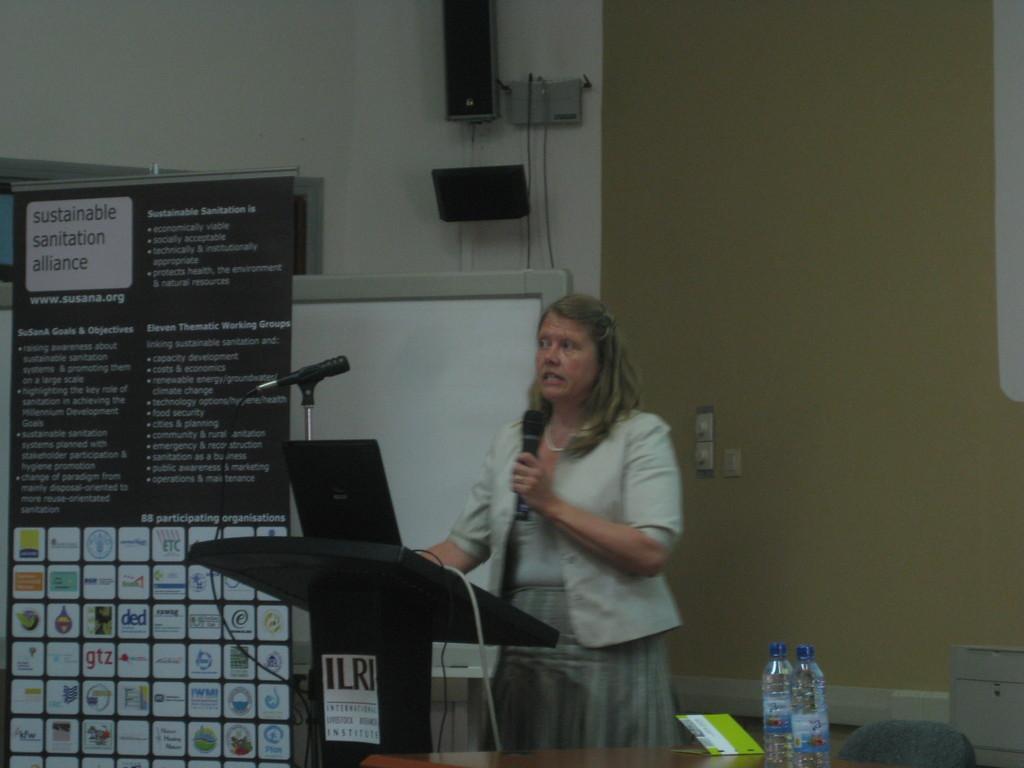In one or two sentences, can you explain what this image depicts? In this picture there is a woman standing and talking and she is holding the microphone. There is a microphone and laptop on the podium and there is a poster on the podium and there is text on the poster. On the left side of the image there is a hoarding and there is text on the hoarding and there is a window. At the back there is a speaker and there are objects on the wall. On the right side of the image there are bottles and there is a book on the table and there is a chair and there is an object. 